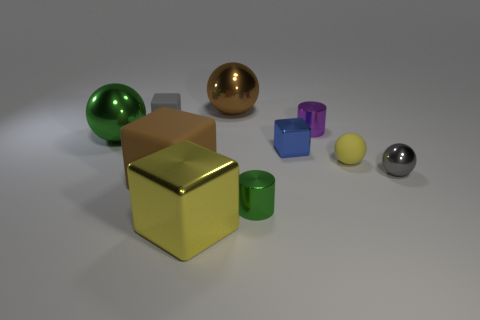Subtract 1 balls. How many balls are left? 3 Subtract all balls. How many objects are left? 6 Subtract all cylinders. Subtract all rubber things. How many objects are left? 5 Add 7 green metal things. How many green metal things are left? 9 Add 7 brown matte cubes. How many brown matte cubes exist? 8 Subtract 0 red cubes. How many objects are left? 10 